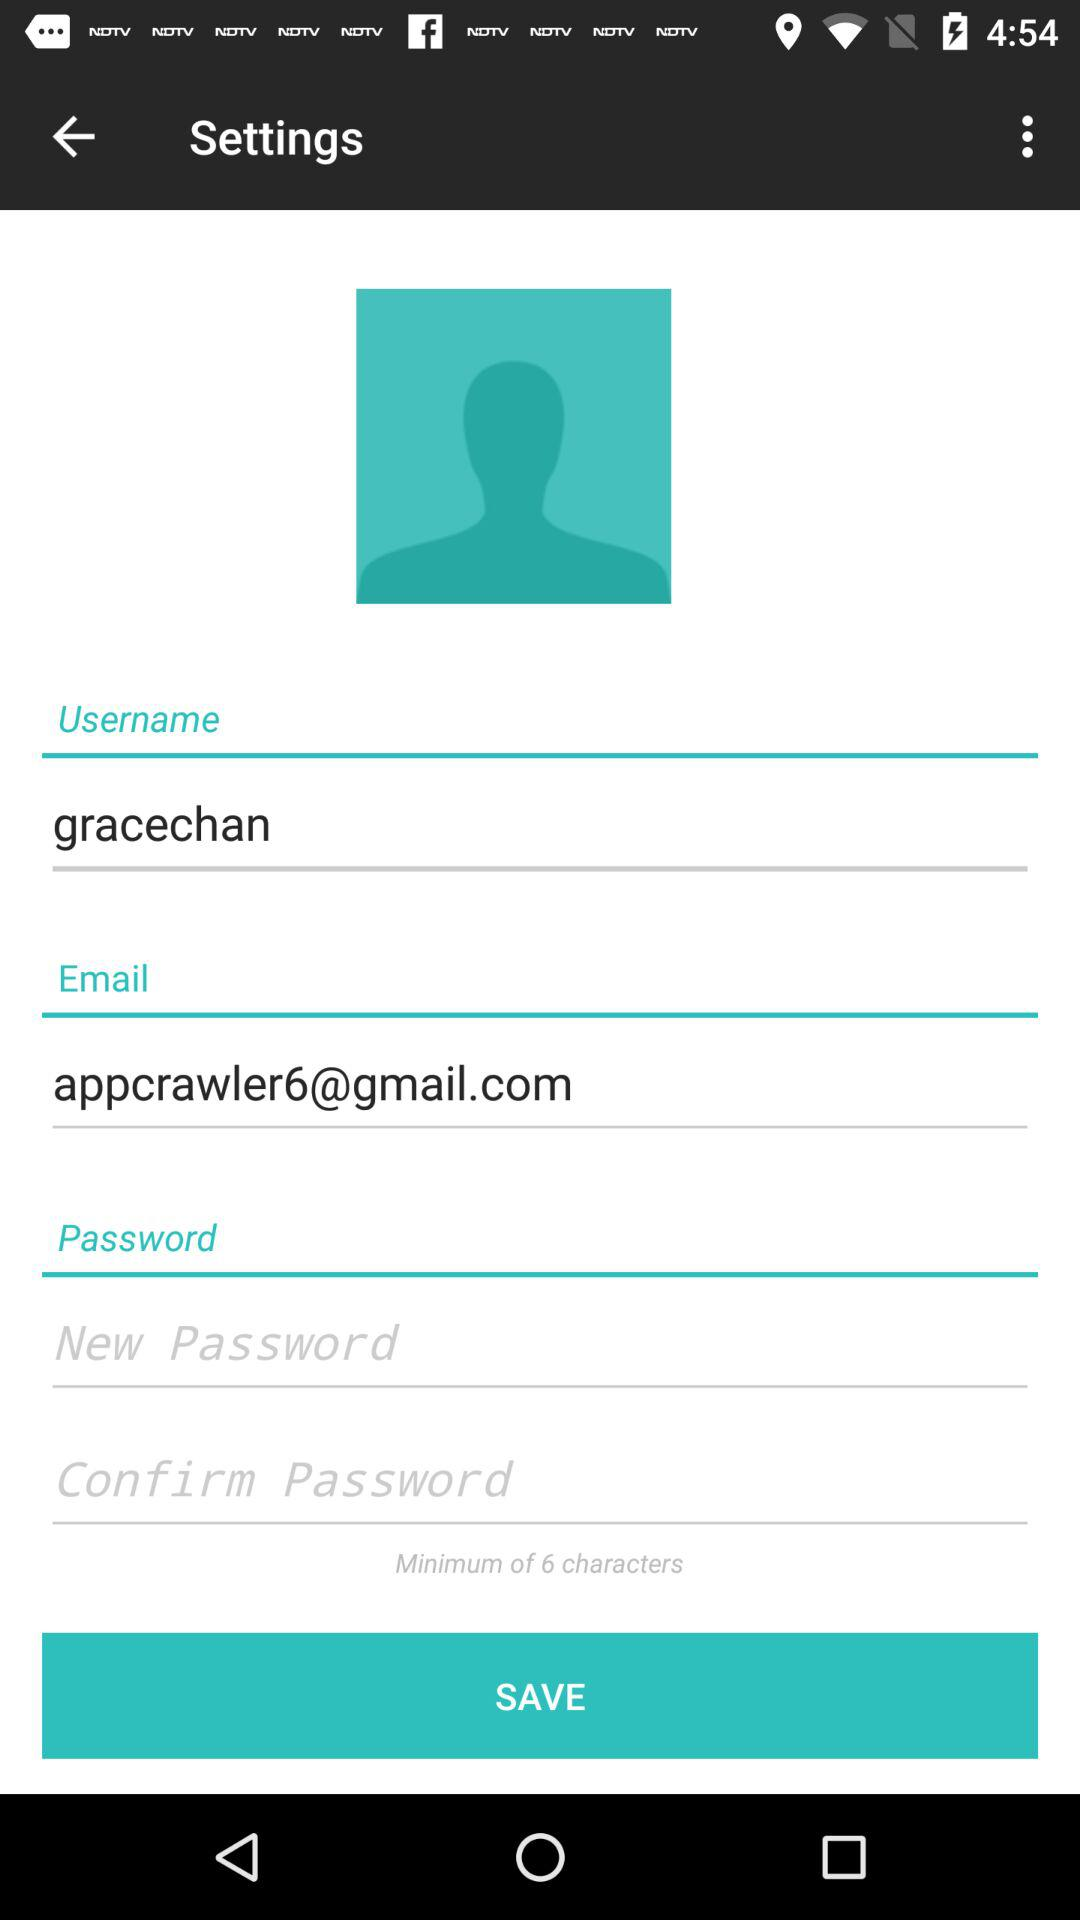What is the username? The username is "gracechan". 